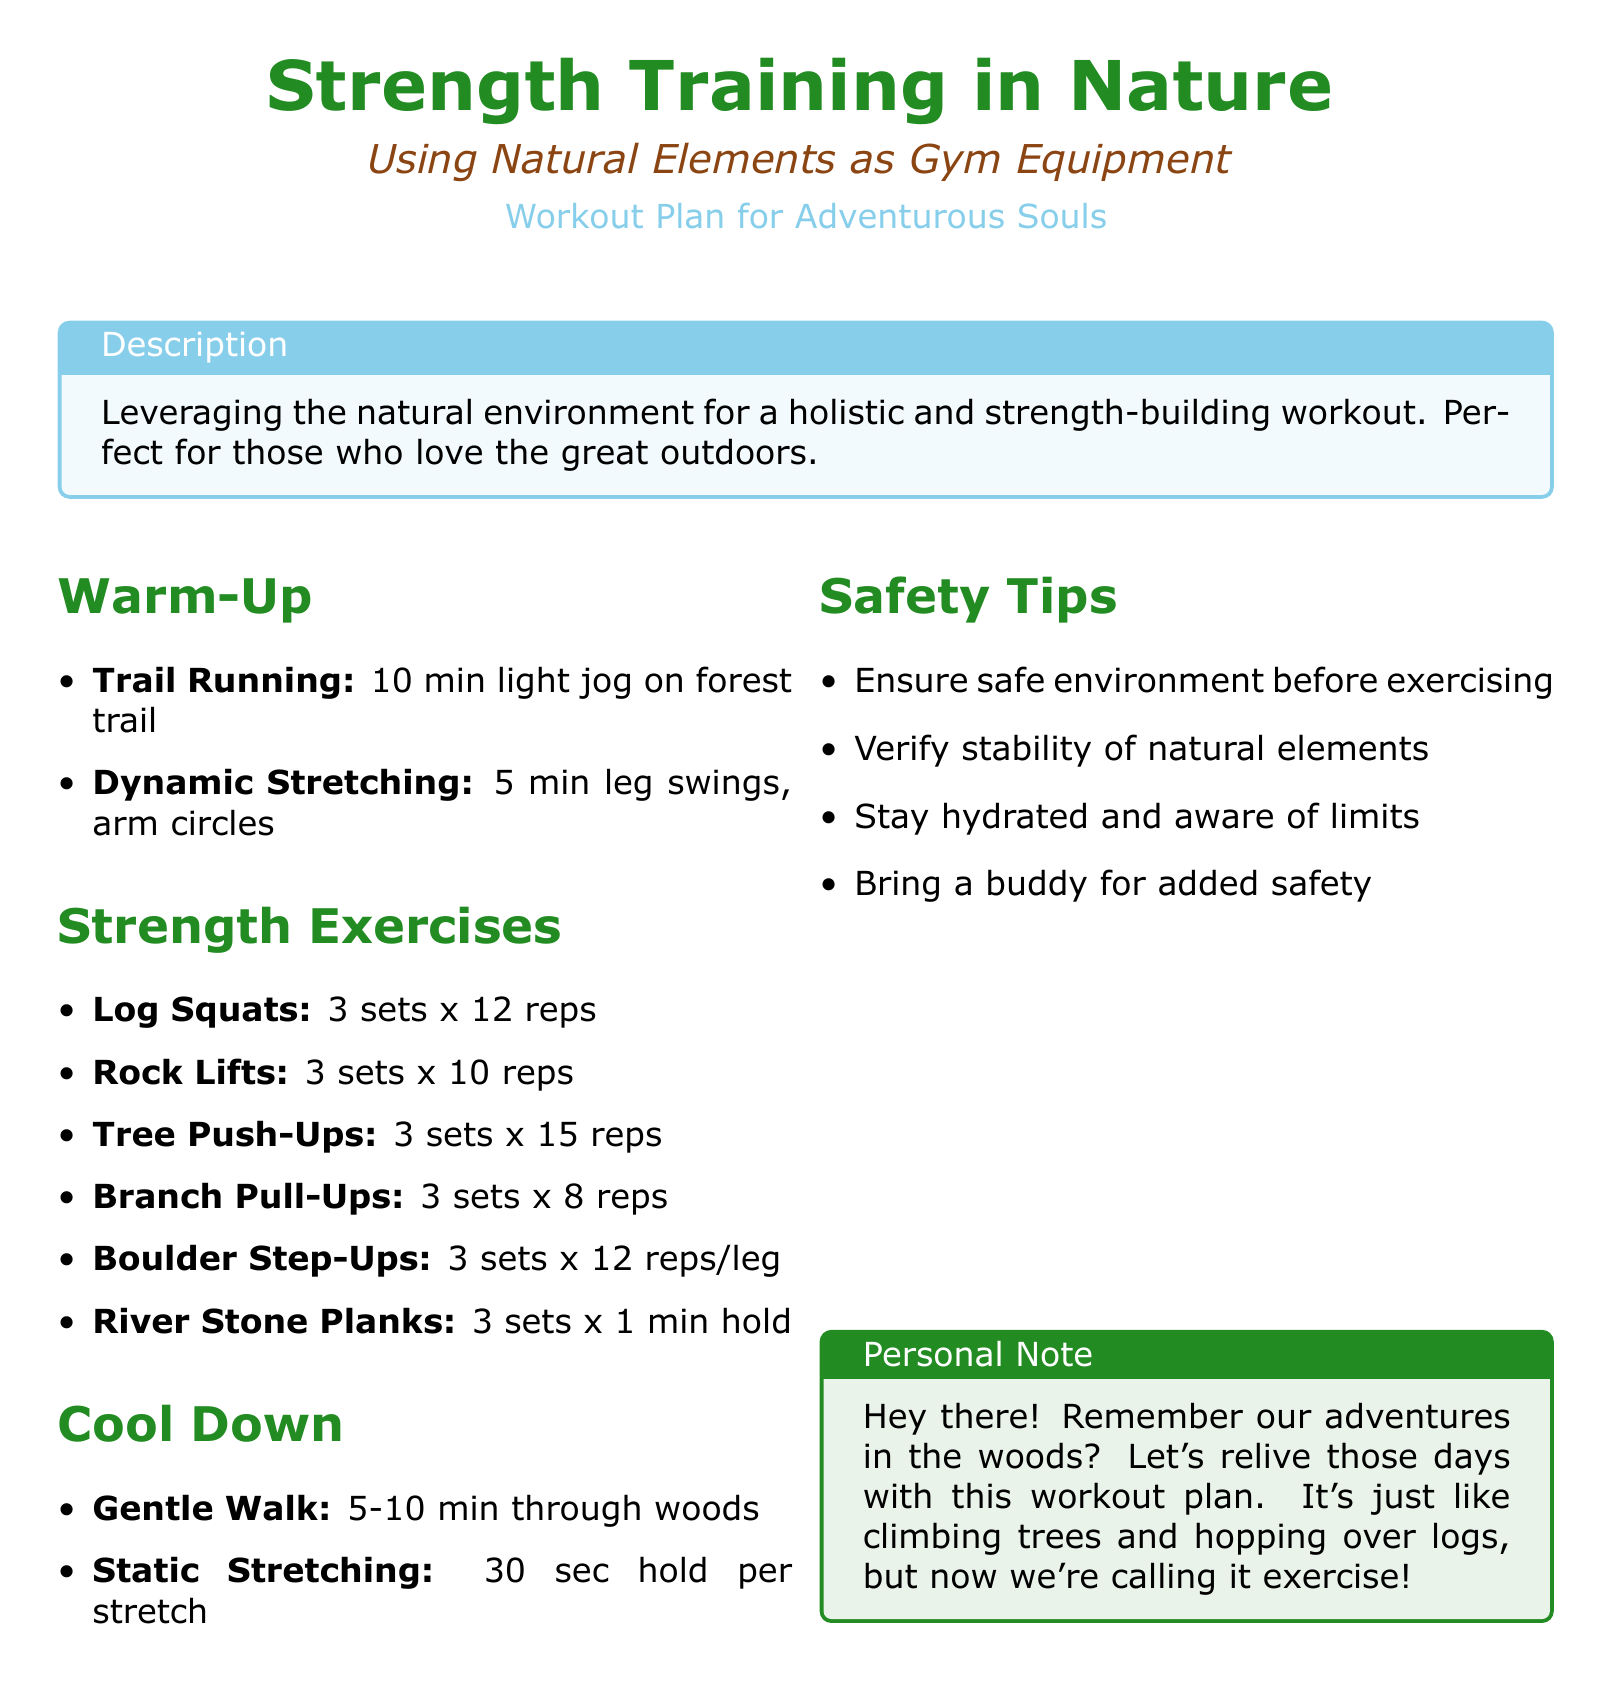What is the title of the workout plan? The title is prominently displayed at the top of the document, indicating the focus of the workout plan.
Answer: Strength Training in Nature How many minutes of light jogging are recommended for the warm-up? The warm-up section outlines specific activities along with their durations.
Answer: 10 min What is the rep count for Log Squats? The strength exercises provide specific rep counts for each exercise listed.
Answer: 12 reps What element is used for the Tree Push-Ups? The strength exercises describe natural elements utilized in the workout routine.
Answer: Tree How long should you hold River Stone Planks? The duration for holding the exercise is specified in the strength exercises section.
Answer: 1 min hold What safety measure involves companionship? The safety tips section advises important practices to follow while exercising outdoors.
Answer: Bring a buddy What is included in the cool down routine after the workout? The cool down section details activities to wind down after the workout session.
Answer: Gentle Walk How many sets are required for the Branch Pull-Ups? The strength exercises outline the number of sets needed for each exercise.
Answer: 3 sets In what environment is this workout plan intended to be performed? The description at the beginning sets the context for where the workout takes place.
Answer: Outdoors 